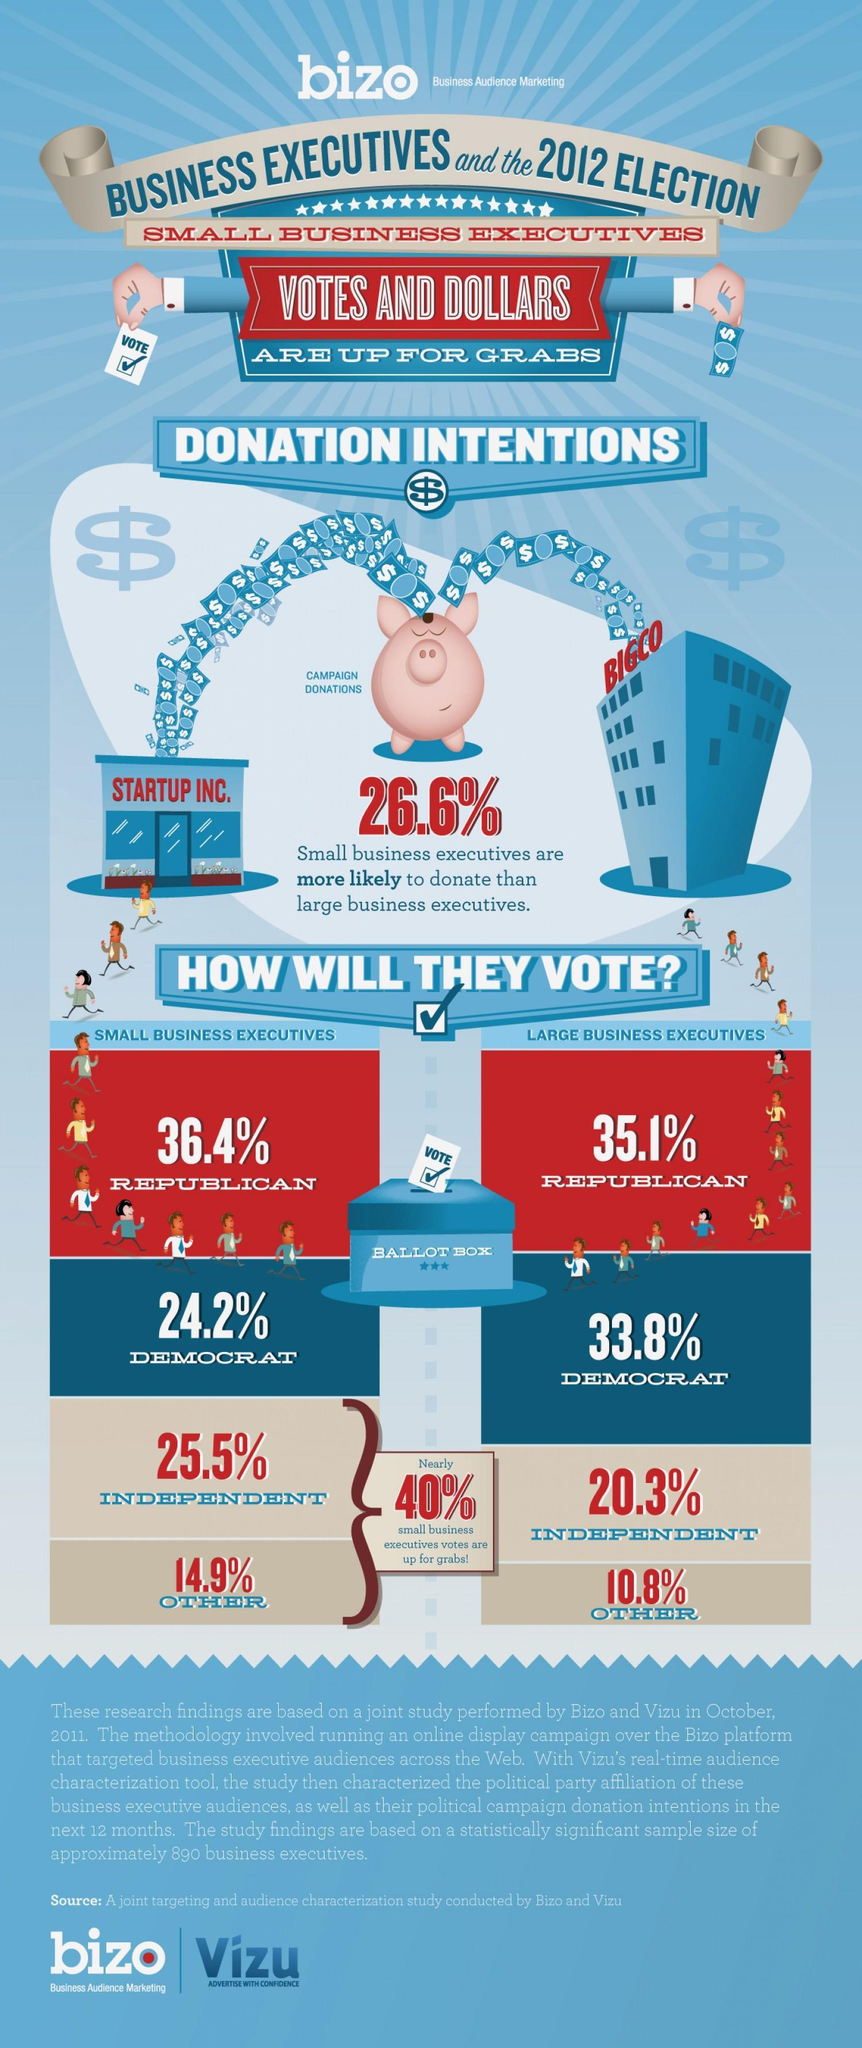What percentage of small business executives will vote for independent party in 2012 US election according to the study performed by Bizo & Vizu in October 2011?
Answer the question with a short phrase. 25.5% What percentage of small business executives  will vote for democratic party in 2012 US election according to the study performed by Bizo & Vizu in October 2011? 24.2% Which party do the majority of the large business executives vote for in 2012 US election according to the study performed by Bizo & Vizu in October 2011? REPUBLICAN 